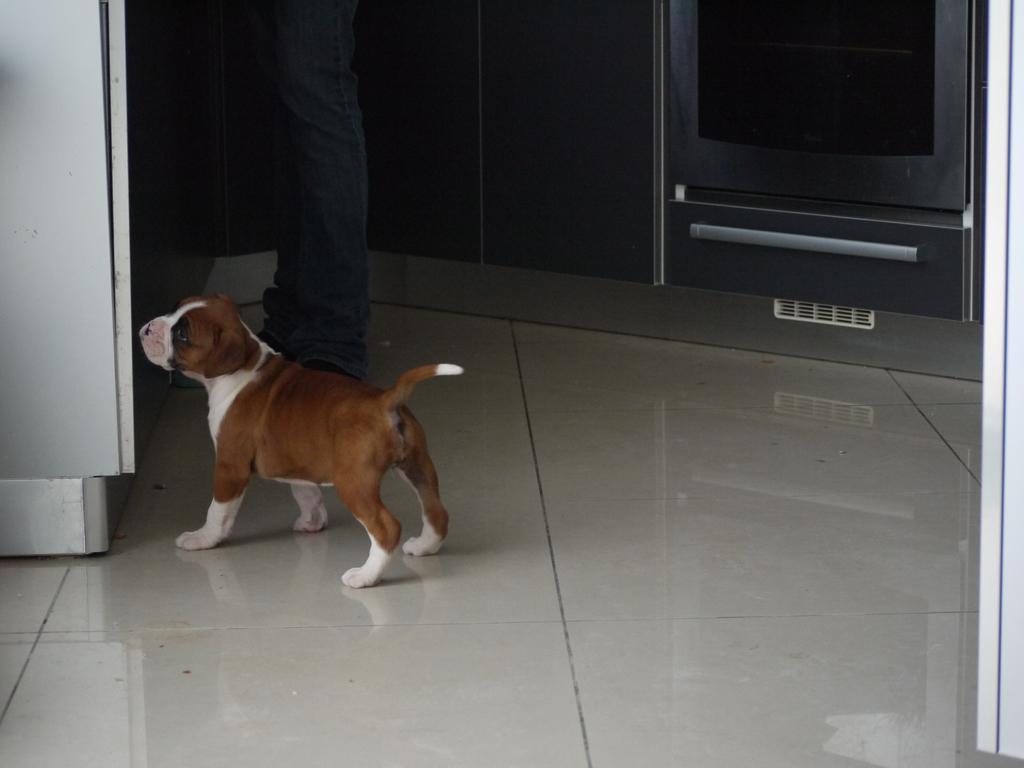In one or two sentences, can you explain what this image depicts? In this there is a dog in the center and there is a person. On the left side there is a fridge and on the right side there is a cup board. 